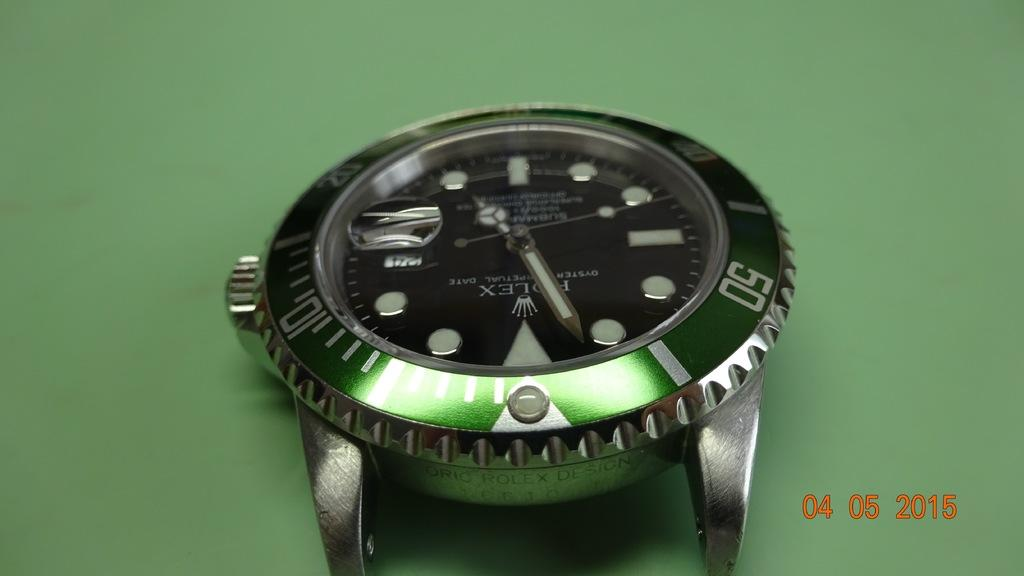<image>
Offer a succinct explanation of the picture presented. a Rolex watch on a green background with date 04 05 2015 on it 